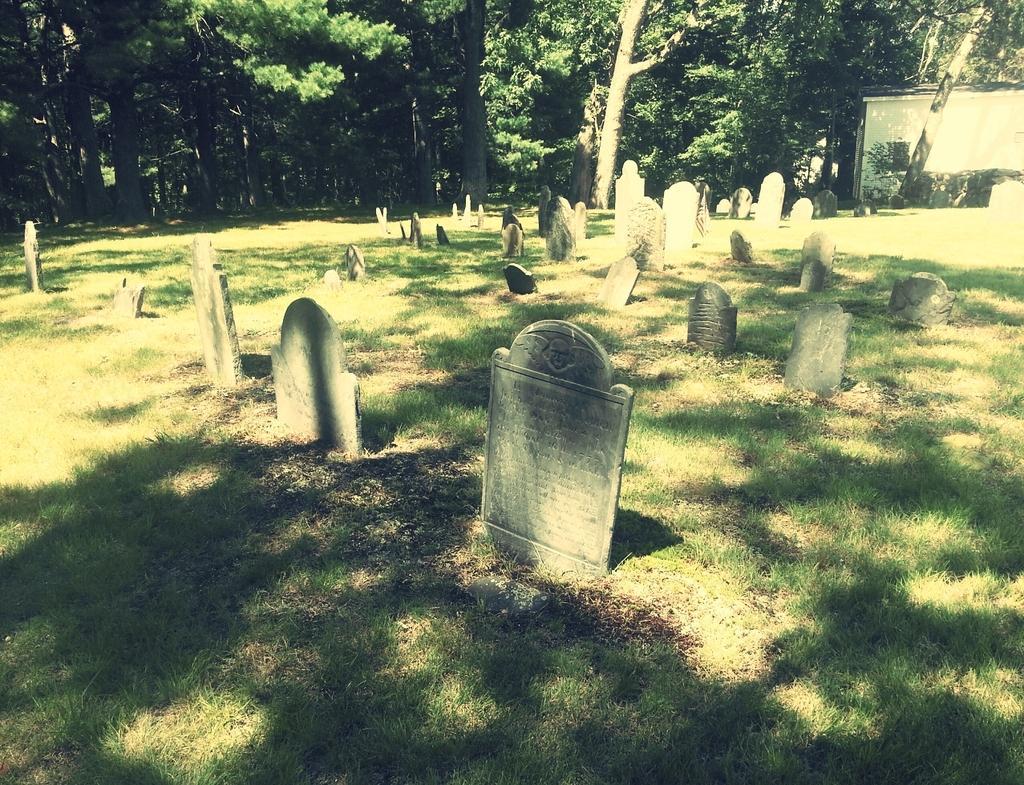How would you summarize this image in a sentence or two? In this image I can see cemetery on the ground. To the right I can see the shed. In the back there are many trees. 